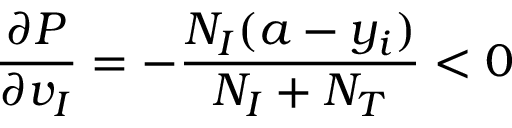<formula> <loc_0><loc_0><loc_500><loc_500>\frac { \partial P } { \partial v _ { I } } = - \frac { N _ { I } ( a - y _ { i } ) } { N _ { I } + N _ { T } } < 0</formula> 